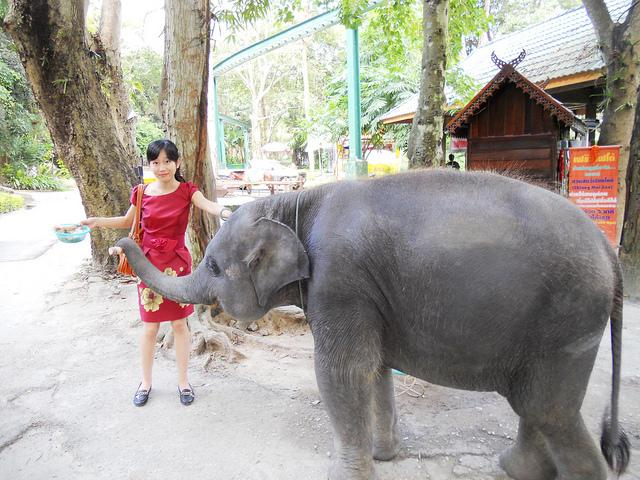What does the elephant here seek?

Choices:
A) love
B) nothing
C) food
D) mate food 